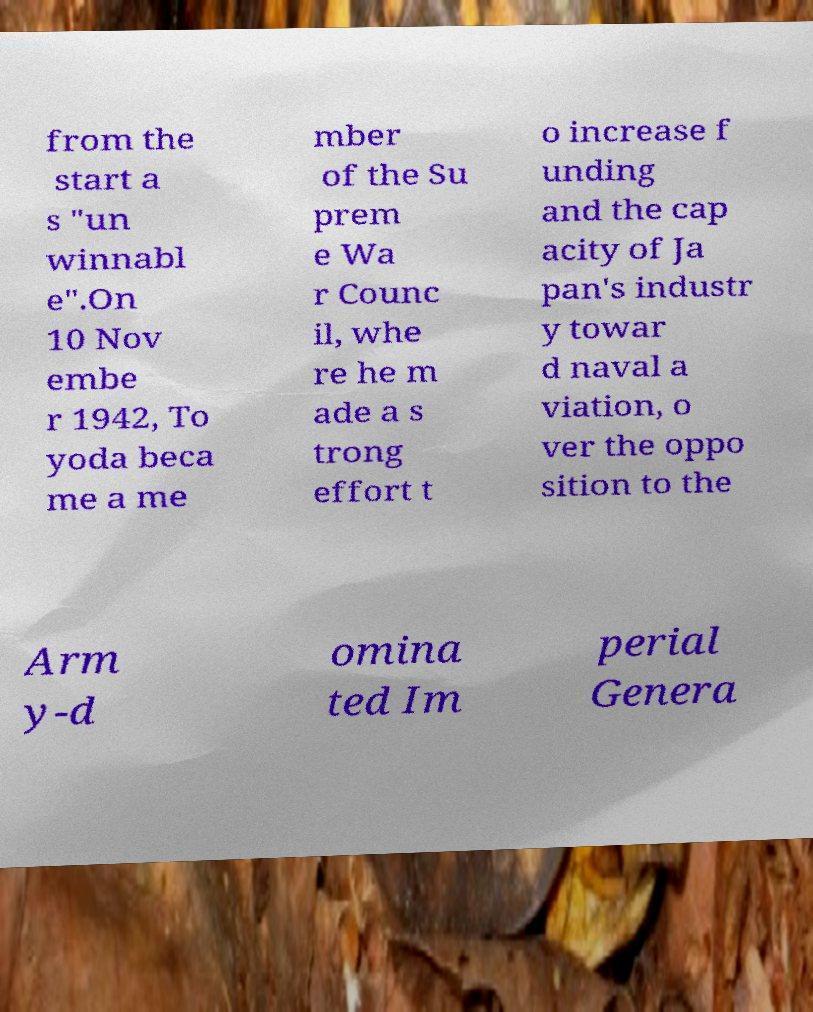For documentation purposes, I need the text within this image transcribed. Could you provide that? from the start a s "un winnabl e".On 10 Nov embe r 1942, To yoda beca me a me mber of the Su prem e Wa r Counc il, whe re he m ade a s trong effort t o increase f unding and the cap acity of Ja pan's industr y towar d naval a viation, o ver the oppo sition to the Arm y-d omina ted Im perial Genera 